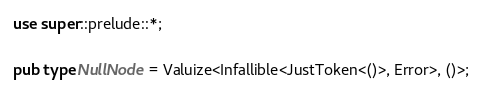Convert code to text. <code><loc_0><loc_0><loc_500><loc_500><_Rust_>use super::prelude::*;

pub type NullNode = Valuize<Infallible<JustToken<()>, Error>, ()>;
</code> 